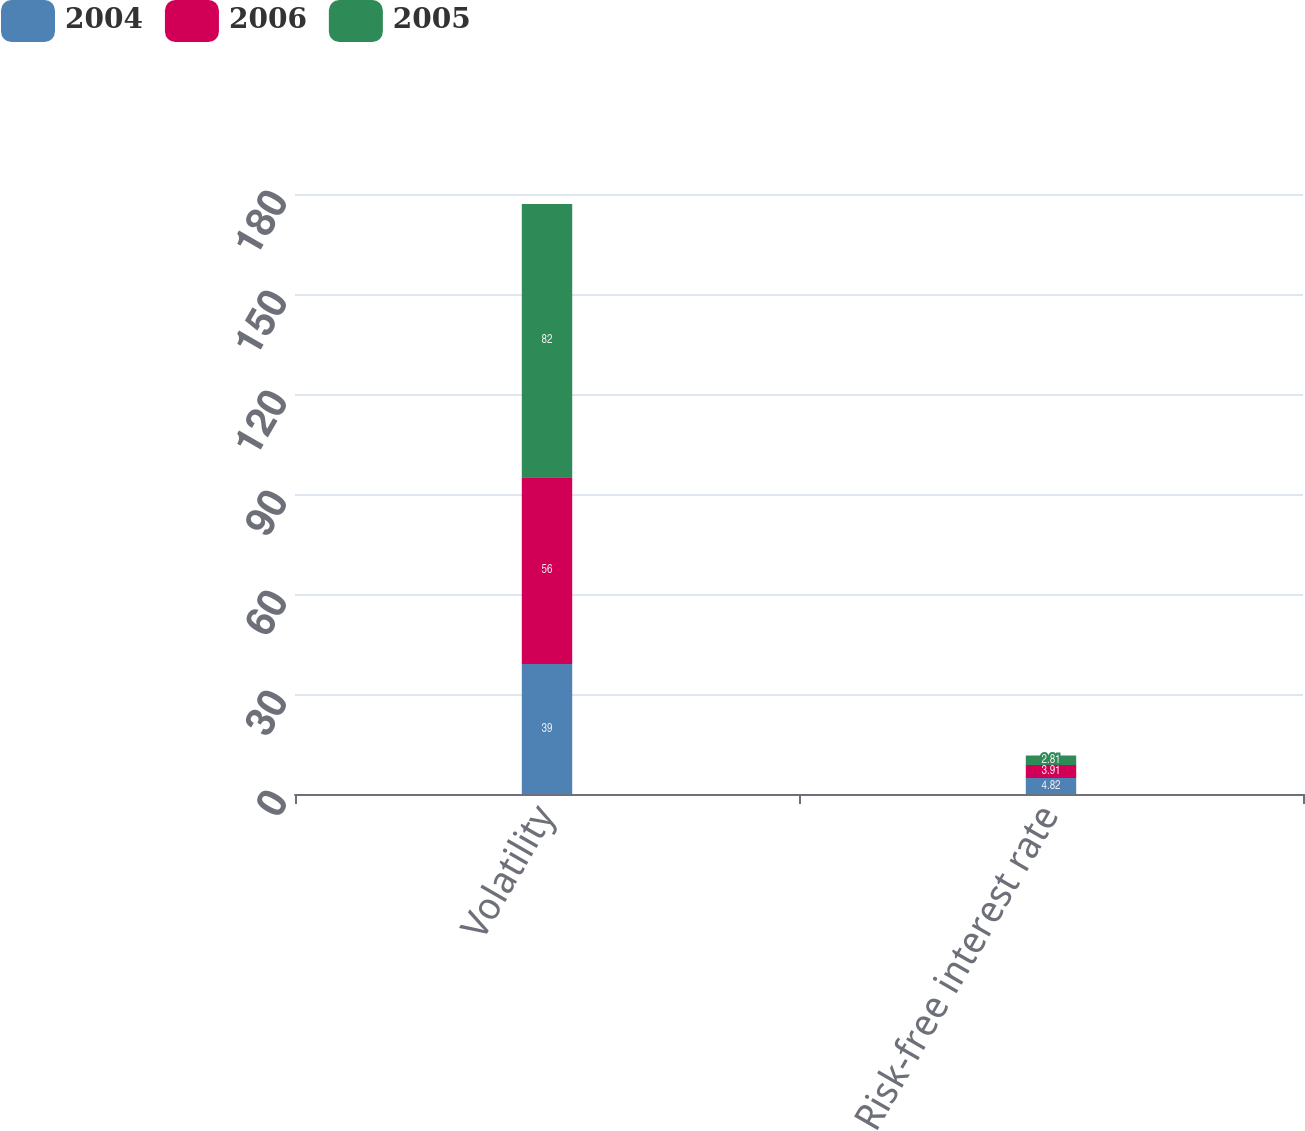<chart> <loc_0><loc_0><loc_500><loc_500><stacked_bar_chart><ecel><fcel>Volatility<fcel>Risk-free interest rate<nl><fcel>2004<fcel>39<fcel>4.82<nl><fcel>2006<fcel>56<fcel>3.91<nl><fcel>2005<fcel>82<fcel>2.81<nl></chart> 